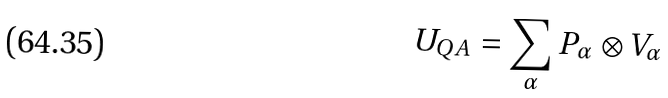Convert formula to latex. <formula><loc_0><loc_0><loc_500><loc_500>U _ { Q A } = \sum _ { \alpha } P _ { \alpha } \otimes V _ { \alpha }</formula> 